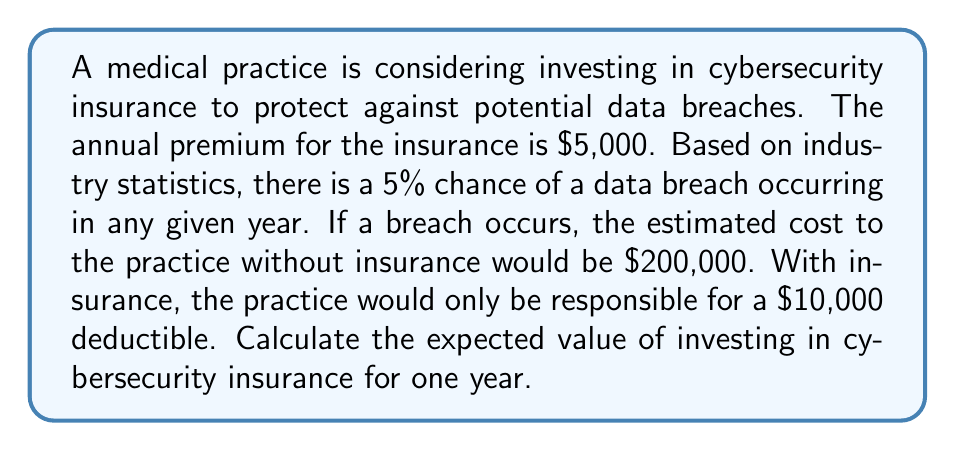Solve this math problem. Let's approach this step-by-step:

1) First, we need to calculate the expected cost without insurance:
   - Probability of a breach: 5% = 0.05
   - Cost of a breach: $200,000
   - Expected cost = $200,000 * 0.05 = $10,000

2) Now, let's calculate the expected cost with insurance:
   - Annual premium: $5,000
   - Probability of a breach: 5% = 0.05
   - Cost to practice if breach occurs (deductible): $10,000
   - Expected cost of breach = $10,000 * 0.05 = $500
   - Total expected cost = Premium + Expected cost of breach
   - Total expected cost = $5,000 + $500 = $5,500

3) The expected value of investing in insurance is the difference between the expected cost without insurance and the expected cost with insurance:

   $$ EV = E(\text{Cost without insurance}) - E(\text{Cost with insurance}) $$
   $$ EV = $10,000 - $5,500 = $4,500 $$

Therefore, the expected value of investing in cybersecurity insurance for one year is $4,500.
Answer: $4,500 